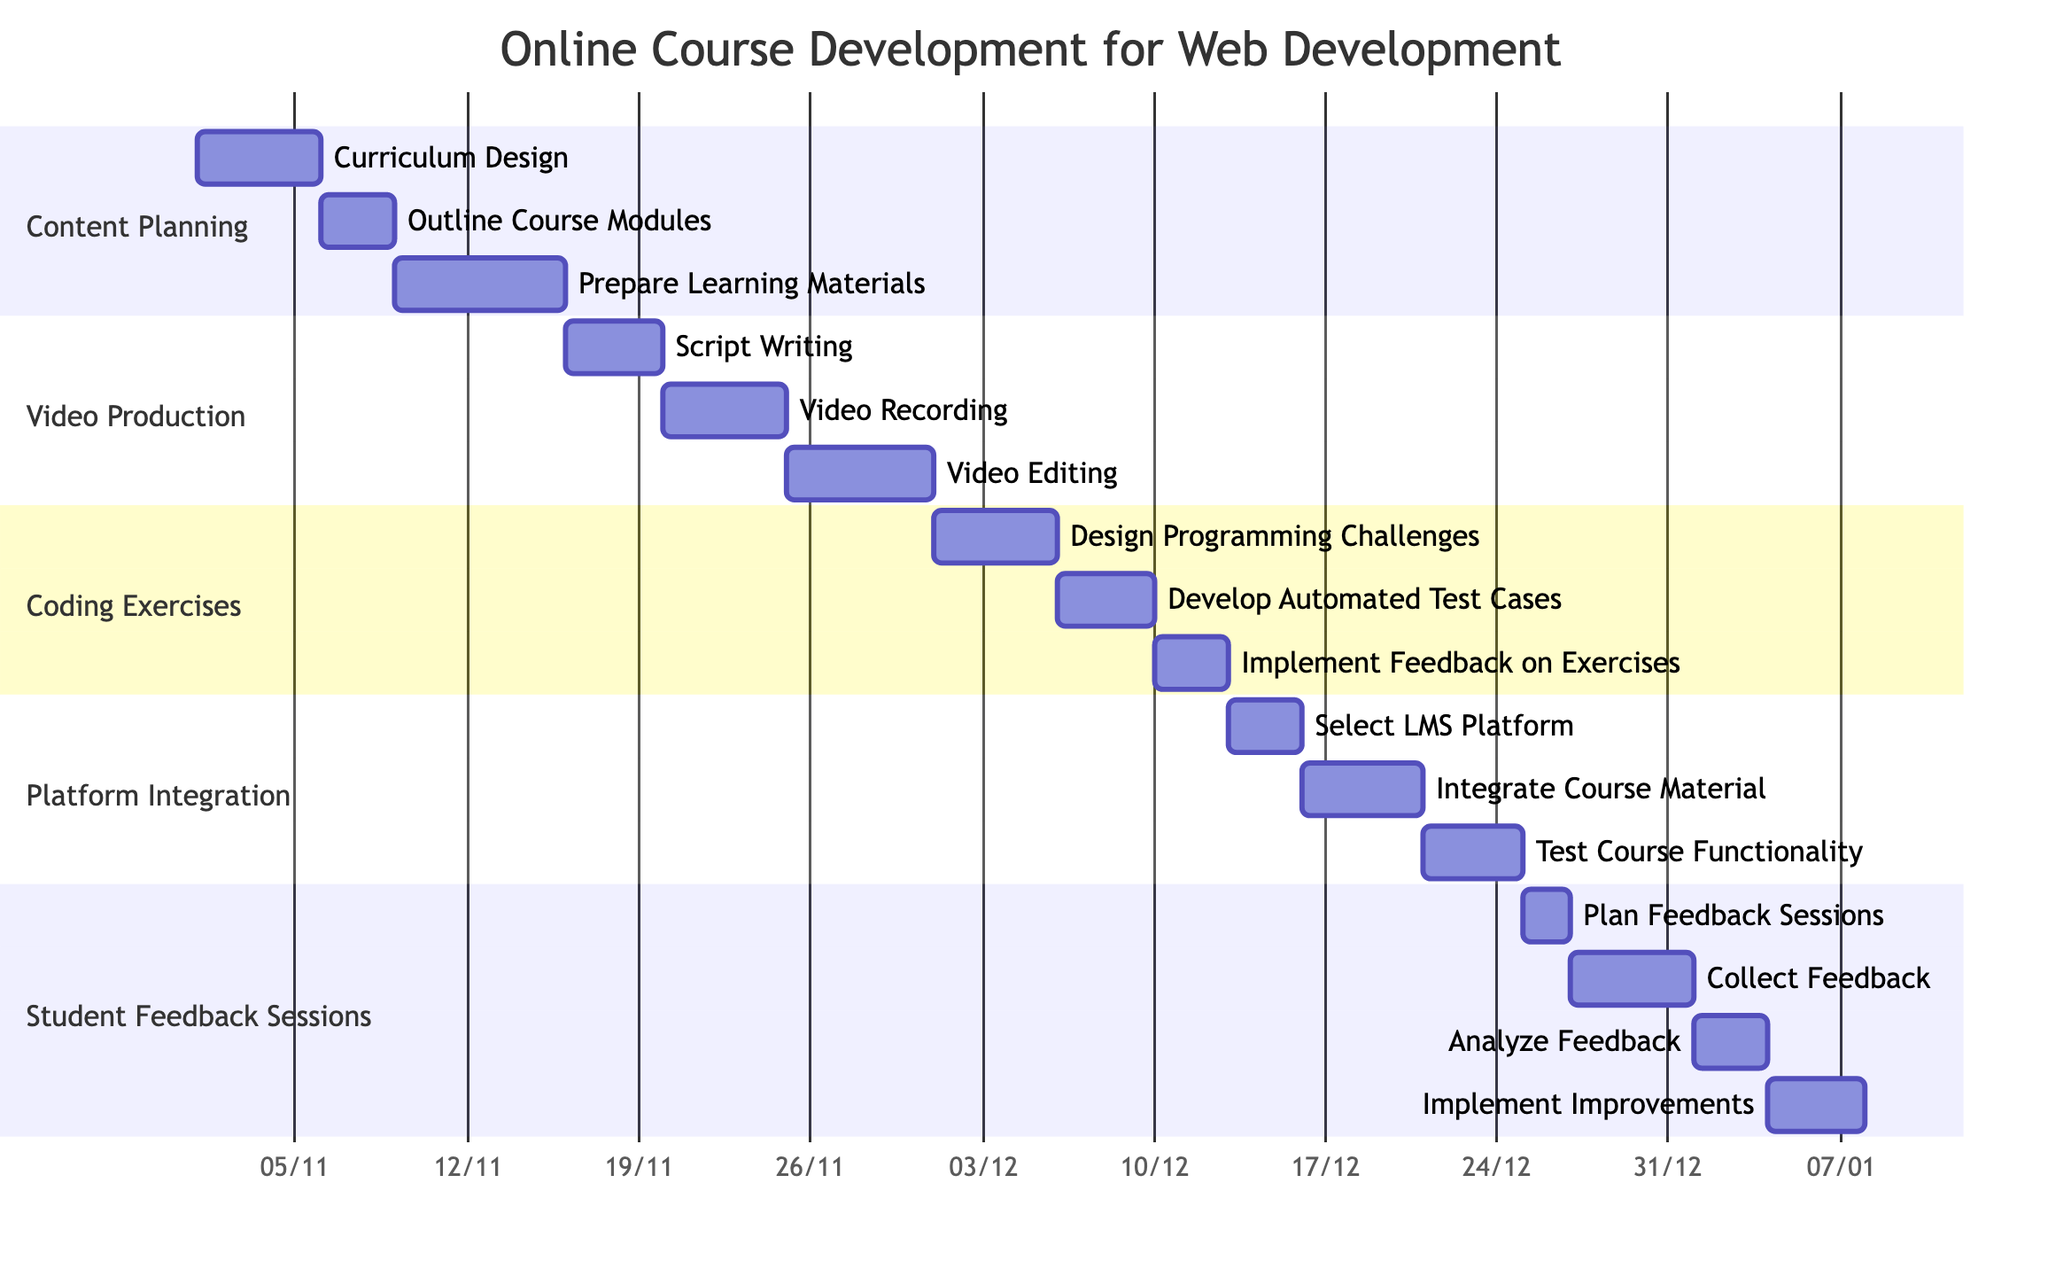What is the duration of the "Prepare Learning Materials" task? The "Prepare Learning Materials" task has a duration of 7 days, as indicated directly on the Gantt chart under the Content Planning section.
Answer: 7 days How many subtasks are under "Video Production"? There are 3 subtasks listed under the "Video Production" section: Script Writing, Video Recording, and Video Editing.
Answer: 3 Which task begins right after "Outline Course Modules"? The task that begins immediately after "Outline Course Modules" is "Prepare Learning Materials," which starts on November 9, 2023.
Answer: Prepare Learning Materials What is the ending date for the "Test Course Functionality" task? The "Test Course Functionality" task ends on December 24, 2023, as shown in the Platform Integration section of the Gantt chart.
Answer: December 24, 2023 Which subtask has the earliest start date? The earliest start date is for the "Curriculum Design" subtask, which starts on November 1, 2023, under the Content Planning section.
Answer: Curriculum Design What is the total duration of all tasks in the "Student Feedback Sessions" section? Adding the durations of all subtasks in the Student Feedback Sessions section: 2 days (Plan Feedback Sessions) + 5 days (Collect Feedback) + 3 days (Analyze Feedback) + 4 days (Implement Improvements) gives a total of 14 days.
Answer: 14 days When does "Develop Automated Test Cases" start? "Develop Automated Test Cases" starts on December 6, 2023, as represented in the Coding Exercises section of the Gantt chart.
Answer: December 6, 2023 What task follows "Video Editing"? There is no task that follows "Video Editing," as it is the last subtask in the Video Production section.
Answer: None How many days are allocated to "Integrate Course Material"? The "Integrate Course Material" task is allocated 5 days in the Gantt chart, starting on December 16, 2023.
Answer: 5 days 